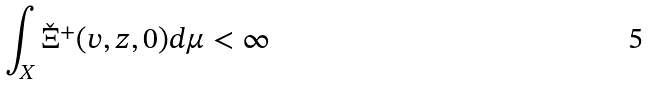<formula> <loc_0><loc_0><loc_500><loc_500>\int _ { X } \check { \Xi } ^ { + } ( v , z , 0 ) d \mu < \infty</formula> 